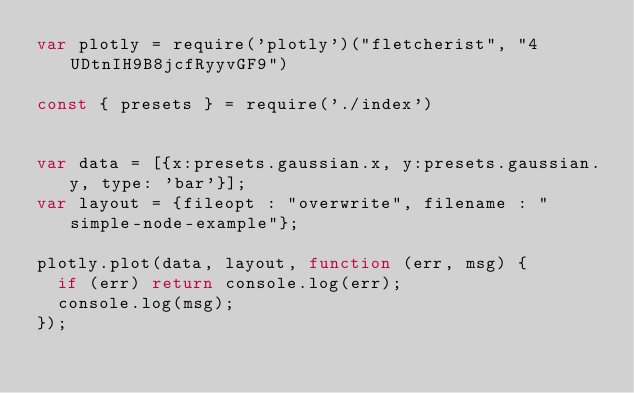Convert code to text. <code><loc_0><loc_0><loc_500><loc_500><_JavaScript_>var plotly = require('plotly')("fletcherist", "4UDtnIH9B8jcfRyyvGF9")

const { presets } = require('./index')


var data = [{x:presets.gaussian.x, y:presets.gaussian.y, type: 'bar'}];
var layout = {fileopt : "overwrite", filename : "simple-node-example"};

plotly.plot(data, layout, function (err, msg) {
  if (err) return console.log(err);
  console.log(msg);
});</code> 